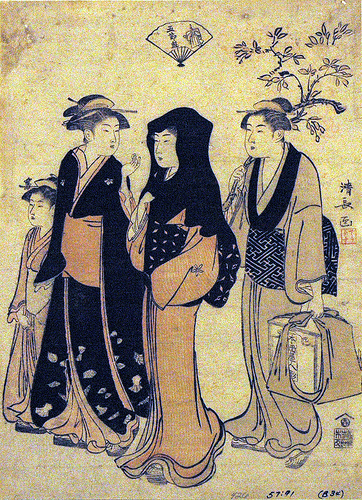<image>
Is the robe on the woman? No. The robe is not positioned on the woman. They may be near each other, but the robe is not supported by or resting on top of the woman. 